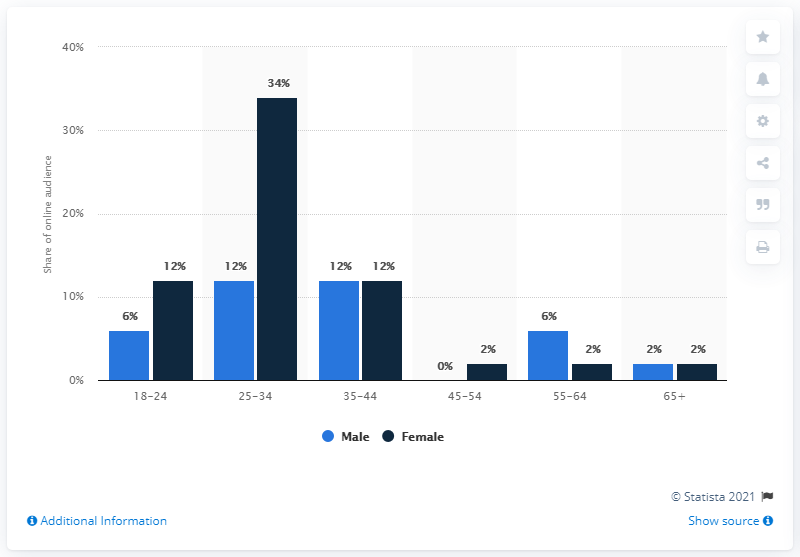Which age group shows the biggest difference in gender
 25-34 